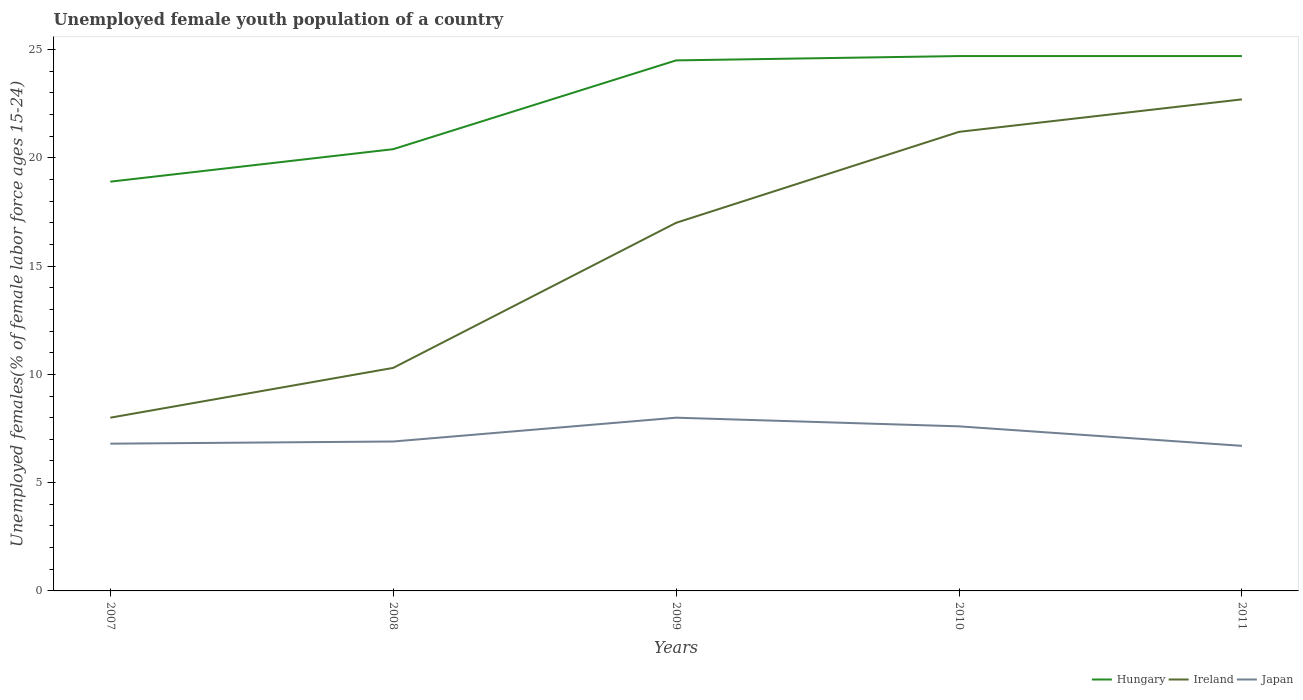Does the line corresponding to Hungary intersect with the line corresponding to Japan?
Offer a very short reply. No. Across all years, what is the maximum percentage of unemployed female youth population in Hungary?
Offer a very short reply. 18.9. In which year was the percentage of unemployed female youth population in Ireland maximum?
Your response must be concise. 2007. What is the total percentage of unemployed female youth population in Ireland in the graph?
Your response must be concise. -5.7. What is the difference between the highest and the second highest percentage of unemployed female youth population in Hungary?
Offer a terse response. 5.8. How many lines are there?
Your answer should be compact. 3. How many years are there in the graph?
Your answer should be very brief. 5. What is the difference between two consecutive major ticks on the Y-axis?
Ensure brevity in your answer.  5. Does the graph contain any zero values?
Your answer should be very brief. No. Does the graph contain grids?
Offer a terse response. No. Where does the legend appear in the graph?
Ensure brevity in your answer.  Bottom right. How many legend labels are there?
Keep it short and to the point. 3. How are the legend labels stacked?
Your response must be concise. Horizontal. What is the title of the graph?
Make the answer very short. Unemployed female youth population of a country. What is the label or title of the Y-axis?
Make the answer very short. Unemployed females(% of female labor force ages 15-24). What is the Unemployed females(% of female labor force ages 15-24) of Hungary in 2007?
Your answer should be very brief. 18.9. What is the Unemployed females(% of female labor force ages 15-24) of Ireland in 2007?
Your answer should be very brief. 8. What is the Unemployed females(% of female labor force ages 15-24) in Japan in 2007?
Your answer should be compact. 6.8. What is the Unemployed females(% of female labor force ages 15-24) of Hungary in 2008?
Offer a very short reply. 20.4. What is the Unemployed females(% of female labor force ages 15-24) of Ireland in 2008?
Offer a terse response. 10.3. What is the Unemployed females(% of female labor force ages 15-24) of Japan in 2008?
Offer a very short reply. 6.9. What is the Unemployed females(% of female labor force ages 15-24) in Hungary in 2009?
Give a very brief answer. 24.5. What is the Unemployed females(% of female labor force ages 15-24) in Japan in 2009?
Provide a short and direct response. 8. What is the Unemployed females(% of female labor force ages 15-24) in Hungary in 2010?
Give a very brief answer. 24.7. What is the Unemployed females(% of female labor force ages 15-24) of Ireland in 2010?
Offer a very short reply. 21.2. What is the Unemployed females(% of female labor force ages 15-24) in Japan in 2010?
Your answer should be compact. 7.6. What is the Unemployed females(% of female labor force ages 15-24) in Hungary in 2011?
Your answer should be very brief. 24.7. What is the Unemployed females(% of female labor force ages 15-24) of Ireland in 2011?
Your answer should be compact. 22.7. What is the Unemployed females(% of female labor force ages 15-24) in Japan in 2011?
Your response must be concise. 6.7. Across all years, what is the maximum Unemployed females(% of female labor force ages 15-24) of Hungary?
Your answer should be compact. 24.7. Across all years, what is the maximum Unemployed females(% of female labor force ages 15-24) of Ireland?
Give a very brief answer. 22.7. Across all years, what is the maximum Unemployed females(% of female labor force ages 15-24) of Japan?
Keep it short and to the point. 8. Across all years, what is the minimum Unemployed females(% of female labor force ages 15-24) of Hungary?
Your answer should be compact. 18.9. Across all years, what is the minimum Unemployed females(% of female labor force ages 15-24) in Ireland?
Offer a terse response. 8. Across all years, what is the minimum Unemployed females(% of female labor force ages 15-24) in Japan?
Your answer should be very brief. 6.7. What is the total Unemployed females(% of female labor force ages 15-24) of Hungary in the graph?
Your answer should be compact. 113.2. What is the total Unemployed females(% of female labor force ages 15-24) of Ireland in the graph?
Your response must be concise. 79.2. What is the total Unemployed females(% of female labor force ages 15-24) in Japan in the graph?
Offer a very short reply. 36. What is the difference between the Unemployed females(% of female labor force ages 15-24) of Ireland in 2007 and that in 2008?
Offer a terse response. -2.3. What is the difference between the Unemployed females(% of female labor force ages 15-24) in Japan in 2007 and that in 2008?
Your answer should be compact. -0.1. What is the difference between the Unemployed females(% of female labor force ages 15-24) of Hungary in 2007 and that in 2009?
Provide a short and direct response. -5.6. What is the difference between the Unemployed females(% of female labor force ages 15-24) in Ireland in 2007 and that in 2010?
Your response must be concise. -13.2. What is the difference between the Unemployed females(% of female labor force ages 15-24) in Japan in 2007 and that in 2010?
Provide a short and direct response. -0.8. What is the difference between the Unemployed females(% of female labor force ages 15-24) in Hungary in 2007 and that in 2011?
Ensure brevity in your answer.  -5.8. What is the difference between the Unemployed females(% of female labor force ages 15-24) of Ireland in 2007 and that in 2011?
Keep it short and to the point. -14.7. What is the difference between the Unemployed females(% of female labor force ages 15-24) in Japan in 2007 and that in 2011?
Give a very brief answer. 0.1. What is the difference between the Unemployed females(% of female labor force ages 15-24) in Ireland in 2008 and that in 2009?
Ensure brevity in your answer.  -6.7. What is the difference between the Unemployed females(% of female labor force ages 15-24) of Japan in 2008 and that in 2009?
Provide a short and direct response. -1.1. What is the difference between the Unemployed females(% of female labor force ages 15-24) of Hungary in 2008 and that in 2010?
Ensure brevity in your answer.  -4.3. What is the difference between the Unemployed females(% of female labor force ages 15-24) in Japan in 2008 and that in 2010?
Make the answer very short. -0.7. What is the difference between the Unemployed females(% of female labor force ages 15-24) in Hungary in 2008 and that in 2011?
Your response must be concise. -4.3. What is the difference between the Unemployed females(% of female labor force ages 15-24) in Ireland in 2008 and that in 2011?
Provide a short and direct response. -12.4. What is the difference between the Unemployed females(% of female labor force ages 15-24) in Japan in 2008 and that in 2011?
Keep it short and to the point. 0.2. What is the difference between the Unemployed females(% of female labor force ages 15-24) in Hungary in 2009 and that in 2010?
Keep it short and to the point. -0.2. What is the difference between the Unemployed females(% of female labor force ages 15-24) in Ireland in 2009 and that in 2010?
Your answer should be very brief. -4.2. What is the difference between the Unemployed females(% of female labor force ages 15-24) in Japan in 2009 and that in 2010?
Make the answer very short. 0.4. What is the difference between the Unemployed females(% of female labor force ages 15-24) in Hungary in 2009 and that in 2011?
Provide a succinct answer. -0.2. What is the difference between the Unemployed females(% of female labor force ages 15-24) in Ireland in 2009 and that in 2011?
Offer a terse response. -5.7. What is the difference between the Unemployed females(% of female labor force ages 15-24) of Hungary in 2010 and that in 2011?
Offer a terse response. 0. What is the difference between the Unemployed females(% of female labor force ages 15-24) of Hungary in 2007 and the Unemployed females(% of female labor force ages 15-24) of Ireland in 2008?
Make the answer very short. 8.6. What is the difference between the Unemployed females(% of female labor force ages 15-24) of Hungary in 2007 and the Unemployed females(% of female labor force ages 15-24) of Japan in 2009?
Your response must be concise. 10.9. What is the difference between the Unemployed females(% of female labor force ages 15-24) in Ireland in 2007 and the Unemployed females(% of female labor force ages 15-24) in Japan in 2009?
Provide a succinct answer. 0. What is the difference between the Unemployed females(% of female labor force ages 15-24) in Hungary in 2007 and the Unemployed females(% of female labor force ages 15-24) in Ireland in 2010?
Give a very brief answer. -2.3. What is the difference between the Unemployed females(% of female labor force ages 15-24) of Ireland in 2007 and the Unemployed females(% of female labor force ages 15-24) of Japan in 2010?
Offer a terse response. 0.4. What is the difference between the Unemployed females(% of female labor force ages 15-24) of Hungary in 2007 and the Unemployed females(% of female labor force ages 15-24) of Japan in 2011?
Ensure brevity in your answer.  12.2. What is the difference between the Unemployed females(% of female labor force ages 15-24) in Ireland in 2007 and the Unemployed females(% of female labor force ages 15-24) in Japan in 2011?
Provide a succinct answer. 1.3. What is the difference between the Unemployed females(% of female labor force ages 15-24) in Hungary in 2008 and the Unemployed females(% of female labor force ages 15-24) in Ireland in 2009?
Give a very brief answer. 3.4. What is the difference between the Unemployed females(% of female labor force ages 15-24) in Ireland in 2008 and the Unemployed females(% of female labor force ages 15-24) in Japan in 2009?
Provide a succinct answer. 2.3. What is the difference between the Unemployed females(% of female labor force ages 15-24) of Hungary in 2008 and the Unemployed females(% of female labor force ages 15-24) of Japan in 2010?
Provide a succinct answer. 12.8. What is the difference between the Unemployed females(% of female labor force ages 15-24) of Ireland in 2008 and the Unemployed females(% of female labor force ages 15-24) of Japan in 2010?
Provide a short and direct response. 2.7. What is the difference between the Unemployed females(% of female labor force ages 15-24) of Hungary in 2008 and the Unemployed females(% of female labor force ages 15-24) of Ireland in 2011?
Your answer should be very brief. -2.3. What is the difference between the Unemployed females(% of female labor force ages 15-24) of Ireland in 2008 and the Unemployed females(% of female labor force ages 15-24) of Japan in 2011?
Offer a terse response. 3.6. What is the difference between the Unemployed females(% of female labor force ages 15-24) of Hungary in 2009 and the Unemployed females(% of female labor force ages 15-24) of Ireland in 2010?
Offer a very short reply. 3.3. What is the difference between the Unemployed females(% of female labor force ages 15-24) of Ireland in 2009 and the Unemployed females(% of female labor force ages 15-24) of Japan in 2010?
Your response must be concise. 9.4. What is the difference between the Unemployed females(% of female labor force ages 15-24) of Hungary in 2009 and the Unemployed females(% of female labor force ages 15-24) of Ireland in 2011?
Ensure brevity in your answer.  1.8. What is the difference between the Unemployed females(% of female labor force ages 15-24) of Hungary in 2009 and the Unemployed females(% of female labor force ages 15-24) of Japan in 2011?
Make the answer very short. 17.8. What is the difference between the Unemployed females(% of female labor force ages 15-24) of Ireland in 2009 and the Unemployed females(% of female labor force ages 15-24) of Japan in 2011?
Provide a short and direct response. 10.3. What is the difference between the Unemployed females(% of female labor force ages 15-24) in Ireland in 2010 and the Unemployed females(% of female labor force ages 15-24) in Japan in 2011?
Give a very brief answer. 14.5. What is the average Unemployed females(% of female labor force ages 15-24) of Hungary per year?
Keep it short and to the point. 22.64. What is the average Unemployed females(% of female labor force ages 15-24) in Ireland per year?
Keep it short and to the point. 15.84. What is the average Unemployed females(% of female labor force ages 15-24) of Japan per year?
Keep it short and to the point. 7.2. In the year 2007, what is the difference between the Unemployed females(% of female labor force ages 15-24) in Hungary and Unemployed females(% of female labor force ages 15-24) in Ireland?
Provide a succinct answer. 10.9. In the year 2007, what is the difference between the Unemployed females(% of female labor force ages 15-24) in Hungary and Unemployed females(% of female labor force ages 15-24) in Japan?
Offer a terse response. 12.1. In the year 2008, what is the difference between the Unemployed females(% of female labor force ages 15-24) of Ireland and Unemployed females(% of female labor force ages 15-24) of Japan?
Your answer should be compact. 3.4. In the year 2009, what is the difference between the Unemployed females(% of female labor force ages 15-24) in Hungary and Unemployed females(% of female labor force ages 15-24) in Ireland?
Your answer should be compact. 7.5. In the year 2010, what is the difference between the Unemployed females(% of female labor force ages 15-24) of Hungary and Unemployed females(% of female labor force ages 15-24) of Japan?
Provide a succinct answer. 17.1. In the year 2010, what is the difference between the Unemployed females(% of female labor force ages 15-24) in Ireland and Unemployed females(% of female labor force ages 15-24) in Japan?
Your answer should be compact. 13.6. In the year 2011, what is the difference between the Unemployed females(% of female labor force ages 15-24) of Hungary and Unemployed females(% of female labor force ages 15-24) of Japan?
Offer a terse response. 18. In the year 2011, what is the difference between the Unemployed females(% of female labor force ages 15-24) in Ireland and Unemployed females(% of female labor force ages 15-24) in Japan?
Your answer should be compact. 16. What is the ratio of the Unemployed females(% of female labor force ages 15-24) in Hungary in 2007 to that in 2008?
Make the answer very short. 0.93. What is the ratio of the Unemployed females(% of female labor force ages 15-24) in Ireland in 2007 to that in 2008?
Ensure brevity in your answer.  0.78. What is the ratio of the Unemployed females(% of female labor force ages 15-24) of Japan in 2007 to that in 2008?
Your answer should be very brief. 0.99. What is the ratio of the Unemployed females(% of female labor force ages 15-24) in Hungary in 2007 to that in 2009?
Offer a terse response. 0.77. What is the ratio of the Unemployed females(% of female labor force ages 15-24) in Ireland in 2007 to that in 2009?
Keep it short and to the point. 0.47. What is the ratio of the Unemployed females(% of female labor force ages 15-24) in Hungary in 2007 to that in 2010?
Your response must be concise. 0.77. What is the ratio of the Unemployed females(% of female labor force ages 15-24) of Ireland in 2007 to that in 2010?
Provide a succinct answer. 0.38. What is the ratio of the Unemployed females(% of female labor force ages 15-24) in Japan in 2007 to that in 2010?
Your answer should be very brief. 0.89. What is the ratio of the Unemployed females(% of female labor force ages 15-24) in Hungary in 2007 to that in 2011?
Your answer should be very brief. 0.77. What is the ratio of the Unemployed females(% of female labor force ages 15-24) of Ireland in 2007 to that in 2011?
Provide a short and direct response. 0.35. What is the ratio of the Unemployed females(% of female labor force ages 15-24) of Japan in 2007 to that in 2011?
Offer a very short reply. 1.01. What is the ratio of the Unemployed females(% of female labor force ages 15-24) of Hungary in 2008 to that in 2009?
Give a very brief answer. 0.83. What is the ratio of the Unemployed females(% of female labor force ages 15-24) in Ireland in 2008 to that in 2009?
Your answer should be compact. 0.61. What is the ratio of the Unemployed females(% of female labor force ages 15-24) of Japan in 2008 to that in 2009?
Keep it short and to the point. 0.86. What is the ratio of the Unemployed females(% of female labor force ages 15-24) of Hungary in 2008 to that in 2010?
Keep it short and to the point. 0.83. What is the ratio of the Unemployed females(% of female labor force ages 15-24) in Ireland in 2008 to that in 2010?
Your answer should be compact. 0.49. What is the ratio of the Unemployed females(% of female labor force ages 15-24) of Japan in 2008 to that in 2010?
Your response must be concise. 0.91. What is the ratio of the Unemployed females(% of female labor force ages 15-24) in Hungary in 2008 to that in 2011?
Your answer should be compact. 0.83. What is the ratio of the Unemployed females(% of female labor force ages 15-24) in Ireland in 2008 to that in 2011?
Offer a terse response. 0.45. What is the ratio of the Unemployed females(% of female labor force ages 15-24) of Japan in 2008 to that in 2011?
Offer a terse response. 1.03. What is the ratio of the Unemployed females(% of female labor force ages 15-24) in Hungary in 2009 to that in 2010?
Make the answer very short. 0.99. What is the ratio of the Unemployed females(% of female labor force ages 15-24) in Ireland in 2009 to that in 2010?
Your answer should be compact. 0.8. What is the ratio of the Unemployed females(% of female labor force ages 15-24) in Japan in 2009 to that in 2010?
Your response must be concise. 1.05. What is the ratio of the Unemployed females(% of female labor force ages 15-24) of Ireland in 2009 to that in 2011?
Keep it short and to the point. 0.75. What is the ratio of the Unemployed females(% of female labor force ages 15-24) of Japan in 2009 to that in 2011?
Provide a succinct answer. 1.19. What is the ratio of the Unemployed females(% of female labor force ages 15-24) of Ireland in 2010 to that in 2011?
Offer a very short reply. 0.93. What is the ratio of the Unemployed females(% of female labor force ages 15-24) in Japan in 2010 to that in 2011?
Your response must be concise. 1.13. What is the difference between the highest and the second highest Unemployed females(% of female labor force ages 15-24) of Hungary?
Offer a very short reply. 0. What is the difference between the highest and the second highest Unemployed females(% of female labor force ages 15-24) of Ireland?
Ensure brevity in your answer.  1.5. What is the difference between the highest and the second highest Unemployed females(% of female labor force ages 15-24) in Japan?
Offer a very short reply. 0.4. What is the difference between the highest and the lowest Unemployed females(% of female labor force ages 15-24) in Hungary?
Offer a terse response. 5.8. What is the difference between the highest and the lowest Unemployed females(% of female labor force ages 15-24) in Ireland?
Provide a short and direct response. 14.7. 